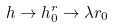Convert formula to latex. <formula><loc_0><loc_0><loc_500><loc_500>h \rightarrow h ^ { r } _ { 0 } \rightarrow \lambda r _ { 0 }</formula> 